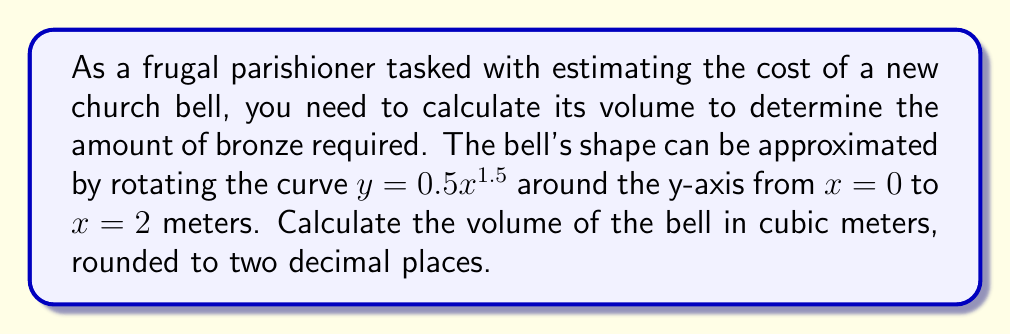Provide a solution to this math problem. To calculate the volume of the church bell, we'll use the washer method of integration, as the bell is formed by rotating a curve around the y-axis.

1. The general formula for the volume of a solid of revolution around the y-axis is:
   $$V = \pi \int_a^b [x(y)]^2 dy$$

2. We need to express x in terms of y:
   $y = 0.5x^{1.5}$
   $x = (2y)^{\frac{2}{3}}$

3. The limits of integration will change:
   When $x = 0$, $y = 0$
   When $x = 2$, $y = 0.5(2)^{1.5} = \sqrt{2}$

4. Substituting into the volume formula:
   $$V = \pi \int_0^{\sqrt{2}} [(2y)^{\frac{2}{3}}]^2 dy$$

5. Simplify:
   $$V = \pi \int_0^{\sqrt{2}} (2y)^{\frac{4}{3}} dy$$
   $$V = \pi \cdot 2^{\frac{4}{3}} \int_0^{\sqrt{2}} y^{\frac{4}{3}} dy$$

6. Integrate:
   $$V = \pi \cdot 2^{\frac{4}{3}} \cdot \frac{3}{7} y^{\frac{7}{3}} \bigg|_0^{\sqrt{2}}$$

7. Evaluate the integral:
   $$V = \pi \cdot 2^{\frac{4}{3}} \cdot \frac{3}{7} \left[(\sqrt{2})^{\frac{7}{3}} - 0^{\frac{7}{3}}\right]$$
   $$V = \pi \cdot 2^{\frac{4}{3}} \cdot \frac{3}{7} \cdot 2^{\frac{7}{6}}$$

8. Simplify:
   $$V = \frac{3\pi}{7} \cdot 2^{\frac{4}{3} + \frac{7}{6}} = \frac{3\pi}{7} \cdot 2^{\frac{15}{6}} = \frac{3\pi}{7} \cdot 2^{\frac{5}{2}}$$

9. Calculate and round to two decimal places:
   $$V \approx 3.35 \text{ m}^3$$
Answer: $3.35 \text{ m}^3$ 